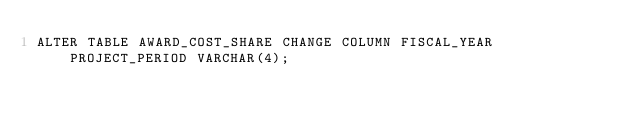<code> <loc_0><loc_0><loc_500><loc_500><_SQL_>ALTER TABLE AWARD_COST_SHARE CHANGE COLUMN FISCAL_YEAR PROJECT_PERIOD VARCHAR(4);</code> 